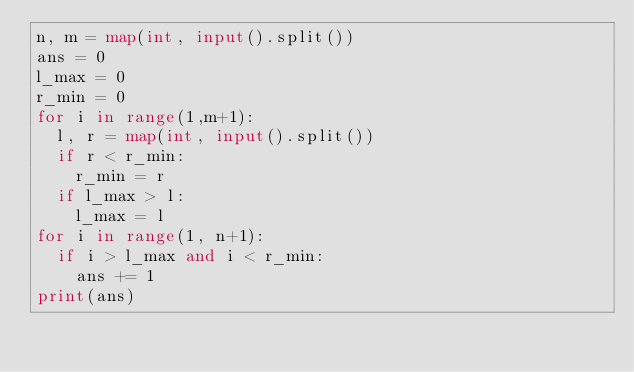<code> <loc_0><loc_0><loc_500><loc_500><_Python_>n, m = map(int, input().split())
ans = 0
l_max = 0
r_min = 0
for i in range(1,m+1):
  l, r = map(int, input().split())
  if r < r_min:
    r_min = r
  if l_max > l:
    l_max = l
for i in range(1, n+1):
  if i > l_max and i < r_min:
    ans += 1
print(ans)

</code> 